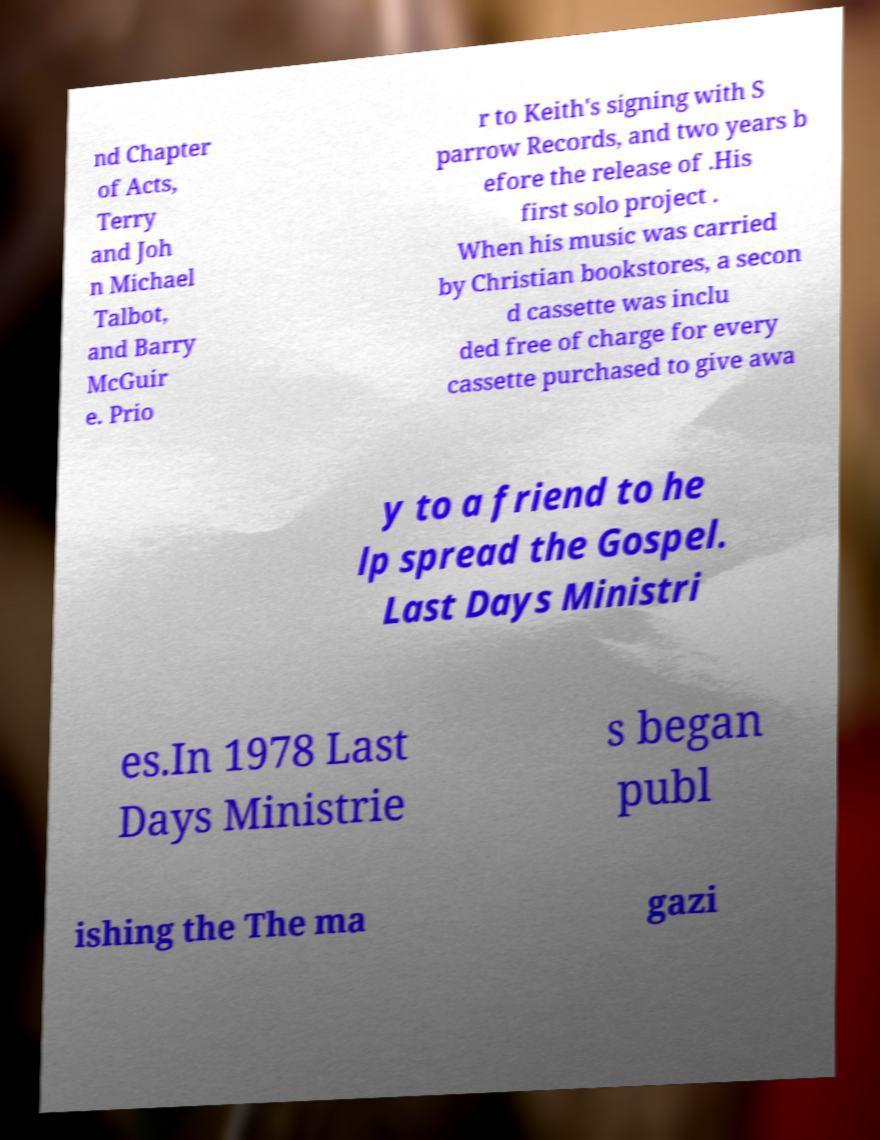For documentation purposes, I need the text within this image transcribed. Could you provide that? nd Chapter of Acts, Terry and Joh n Michael Talbot, and Barry McGuir e. Prio r to Keith's signing with S parrow Records, and two years b efore the release of .His first solo project . When his music was carried by Christian bookstores, a secon d cassette was inclu ded free of charge for every cassette purchased to give awa y to a friend to he lp spread the Gospel. Last Days Ministri es.In 1978 Last Days Ministrie s began publ ishing the The ma gazi 